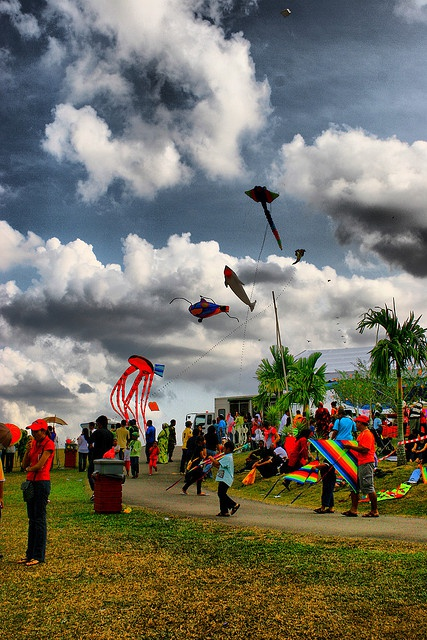Describe the objects in this image and their specific colors. I can see people in darkblue, black, olive, maroon, and red tones, people in darkblue, black, maroon, and red tones, kite in darkblue, red, brown, darkgray, and lightgray tones, people in darkblue, black, red, and maroon tones, and kite in darkblue, red, black, navy, and blue tones in this image. 